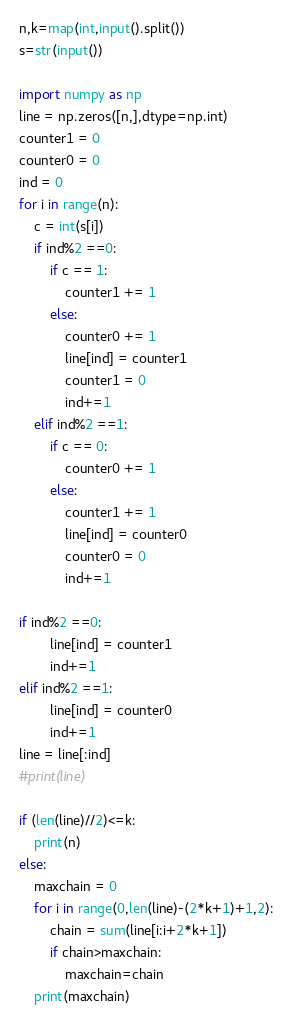Convert code to text. <code><loc_0><loc_0><loc_500><loc_500><_Python_>n,k=map(int,input().split())
s=str(input())

import numpy as np
line = np.zeros([n,],dtype=np.int)
counter1 = 0
counter0 = 0
ind = 0
for i in range(n):
    c = int(s[i])
    if ind%2 ==0:
        if c == 1:
            counter1 += 1
        else:
            counter0 += 1
            line[ind] = counter1
            counter1 = 0
            ind+=1
    elif ind%2 ==1:
        if c == 0:
            counter0 += 1
        else:
            counter1 += 1
            line[ind] = counter0
            counter0 = 0
            ind+=1

if ind%2 ==0:
        line[ind] = counter1
        ind+=1
elif ind%2 ==1:
        line[ind] = counter0
        ind+=1
line = line[:ind]    
#print(line)

if (len(line)//2)<=k:
    print(n)
else:
    maxchain = 0
    for i in range(0,len(line)-(2*k+1)+1,2):
        chain = sum(line[i:i+2*k+1])
        if chain>maxchain:
            maxchain=chain
    print(maxchain)</code> 